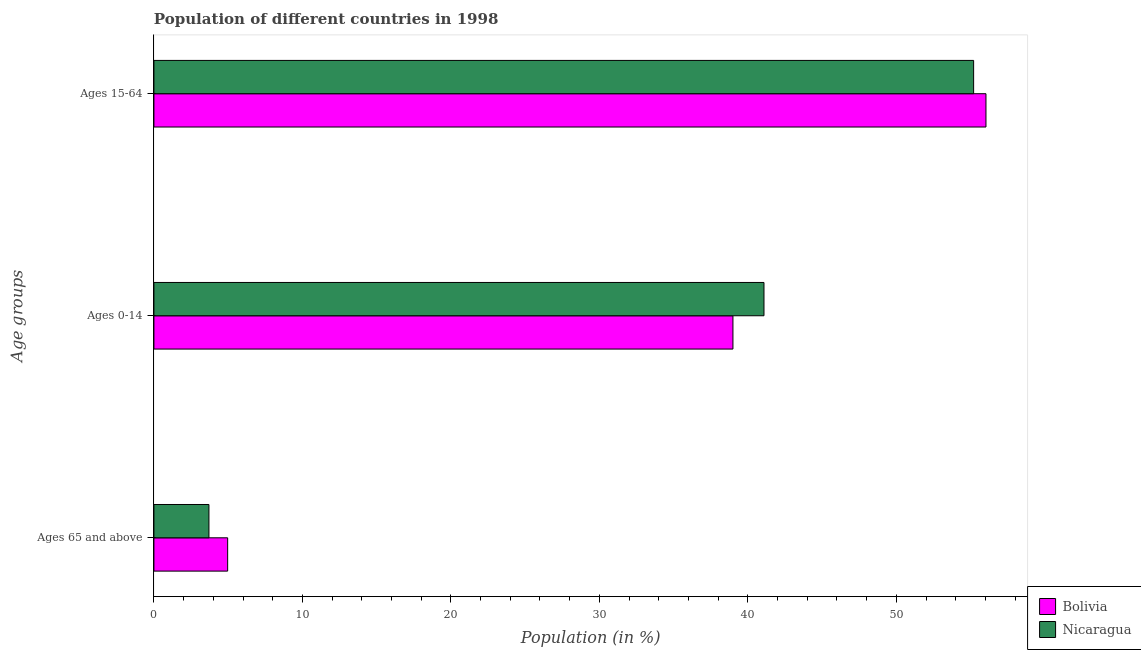How many groups of bars are there?
Your answer should be very brief. 3. Are the number of bars on each tick of the Y-axis equal?
Keep it short and to the point. Yes. What is the label of the 3rd group of bars from the top?
Your response must be concise. Ages 65 and above. What is the percentage of population within the age-group 15-64 in Nicaragua?
Provide a short and direct response. 55.21. Across all countries, what is the maximum percentage of population within the age-group of 65 and above?
Offer a very short reply. 4.97. Across all countries, what is the minimum percentage of population within the age-group 0-14?
Your answer should be very brief. 39. In which country was the percentage of population within the age-group 15-64 maximum?
Provide a short and direct response. Bolivia. What is the total percentage of population within the age-group 0-14 in the graph?
Offer a terse response. 80.08. What is the difference between the percentage of population within the age-group 0-14 in Bolivia and that in Nicaragua?
Give a very brief answer. -2.09. What is the difference between the percentage of population within the age-group 0-14 in Bolivia and the percentage of population within the age-group of 65 and above in Nicaragua?
Offer a terse response. 35.29. What is the average percentage of population within the age-group of 65 and above per country?
Provide a short and direct response. 4.34. What is the difference between the percentage of population within the age-group of 65 and above and percentage of population within the age-group 0-14 in Nicaragua?
Your answer should be compact. -37.38. What is the ratio of the percentage of population within the age-group 0-14 in Nicaragua to that in Bolivia?
Your answer should be compact. 1.05. Is the percentage of population within the age-group 0-14 in Nicaragua less than that in Bolivia?
Your response must be concise. No. What is the difference between the highest and the second highest percentage of population within the age-group of 65 and above?
Ensure brevity in your answer.  1.26. What is the difference between the highest and the lowest percentage of population within the age-group of 65 and above?
Your response must be concise. 1.26. What does the 2nd bar from the top in Ages 15-64 represents?
Provide a short and direct response. Bolivia. What does the 2nd bar from the bottom in Ages 0-14 represents?
Provide a succinct answer. Nicaragua. Is it the case that in every country, the sum of the percentage of population within the age-group of 65 and above and percentage of population within the age-group 0-14 is greater than the percentage of population within the age-group 15-64?
Provide a short and direct response. No. Are the values on the major ticks of X-axis written in scientific E-notation?
Your answer should be very brief. No. Where does the legend appear in the graph?
Provide a succinct answer. Bottom right. How are the legend labels stacked?
Offer a terse response. Vertical. What is the title of the graph?
Give a very brief answer. Population of different countries in 1998. Does "Ukraine" appear as one of the legend labels in the graph?
Provide a succinct answer. No. What is the label or title of the Y-axis?
Your answer should be compact. Age groups. What is the Population (in %) in Bolivia in Ages 65 and above?
Make the answer very short. 4.97. What is the Population (in %) in Nicaragua in Ages 65 and above?
Ensure brevity in your answer.  3.71. What is the Population (in %) in Bolivia in Ages 0-14?
Offer a very short reply. 39. What is the Population (in %) of Nicaragua in Ages 0-14?
Keep it short and to the point. 41.09. What is the Population (in %) of Bolivia in Ages 15-64?
Your answer should be compact. 56.04. What is the Population (in %) in Nicaragua in Ages 15-64?
Your answer should be compact. 55.21. Across all Age groups, what is the maximum Population (in %) in Bolivia?
Make the answer very short. 56.04. Across all Age groups, what is the maximum Population (in %) in Nicaragua?
Make the answer very short. 55.21. Across all Age groups, what is the minimum Population (in %) of Bolivia?
Give a very brief answer. 4.97. Across all Age groups, what is the minimum Population (in %) in Nicaragua?
Keep it short and to the point. 3.71. What is the total Population (in %) of Nicaragua in the graph?
Provide a short and direct response. 100. What is the difference between the Population (in %) of Bolivia in Ages 65 and above and that in Ages 0-14?
Ensure brevity in your answer.  -34.03. What is the difference between the Population (in %) in Nicaragua in Ages 65 and above and that in Ages 0-14?
Offer a terse response. -37.38. What is the difference between the Population (in %) of Bolivia in Ages 65 and above and that in Ages 15-64?
Your response must be concise. -51.07. What is the difference between the Population (in %) in Nicaragua in Ages 65 and above and that in Ages 15-64?
Your answer should be compact. -51.5. What is the difference between the Population (in %) of Bolivia in Ages 0-14 and that in Ages 15-64?
Offer a terse response. -17.04. What is the difference between the Population (in %) in Nicaragua in Ages 0-14 and that in Ages 15-64?
Offer a terse response. -14.12. What is the difference between the Population (in %) of Bolivia in Ages 65 and above and the Population (in %) of Nicaragua in Ages 0-14?
Ensure brevity in your answer.  -36.12. What is the difference between the Population (in %) in Bolivia in Ages 65 and above and the Population (in %) in Nicaragua in Ages 15-64?
Offer a terse response. -50.24. What is the difference between the Population (in %) in Bolivia in Ages 0-14 and the Population (in %) in Nicaragua in Ages 15-64?
Ensure brevity in your answer.  -16.21. What is the average Population (in %) of Bolivia per Age groups?
Your answer should be very brief. 33.33. What is the average Population (in %) of Nicaragua per Age groups?
Offer a very short reply. 33.33. What is the difference between the Population (in %) of Bolivia and Population (in %) of Nicaragua in Ages 65 and above?
Make the answer very short. 1.26. What is the difference between the Population (in %) in Bolivia and Population (in %) in Nicaragua in Ages 0-14?
Offer a very short reply. -2.09. What is the difference between the Population (in %) in Bolivia and Population (in %) in Nicaragua in Ages 15-64?
Ensure brevity in your answer.  0.83. What is the ratio of the Population (in %) of Bolivia in Ages 65 and above to that in Ages 0-14?
Keep it short and to the point. 0.13. What is the ratio of the Population (in %) of Nicaragua in Ages 65 and above to that in Ages 0-14?
Provide a short and direct response. 0.09. What is the ratio of the Population (in %) of Bolivia in Ages 65 and above to that in Ages 15-64?
Ensure brevity in your answer.  0.09. What is the ratio of the Population (in %) of Nicaragua in Ages 65 and above to that in Ages 15-64?
Keep it short and to the point. 0.07. What is the ratio of the Population (in %) of Bolivia in Ages 0-14 to that in Ages 15-64?
Ensure brevity in your answer.  0.7. What is the ratio of the Population (in %) of Nicaragua in Ages 0-14 to that in Ages 15-64?
Make the answer very short. 0.74. What is the difference between the highest and the second highest Population (in %) in Bolivia?
Offer a very short reply. 17.04. What is the difference between the highest and the second highest Population (in %) in Nicaragua?
Provide a short and direct response. 14.12. What is the difference between the highest and the lowest Population (in %) of Bolivia?
Provide a short and direct response. 51.07. What is the difference between the highest and the lowest Population (in %) of Nicaragua?
Ensure brevity in your answer.  51.5. 